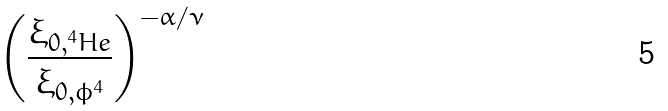<formula> <loc_0><loc_0><loc_500><loc_500>\left ( \frac { \xi _ { 0 , ^ { 4 } H e } } { \xi _ { 0 , \phi ^ { 4 } } } \right ) ^ { - \alpha / \nu }</formula> 